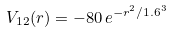<formula> <loc_0><loc_0><loc_500><loc_500>V _ { 1 2 } ( r ) = - 8 0 \, e ^ { - r ^ { 2 } / 1 . 6 ^ { 3 } }</formula> 